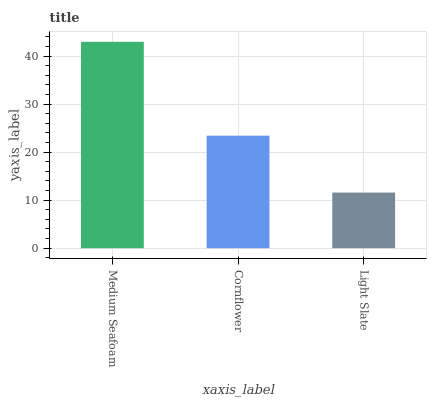Is Light Slate the minimum?
Answer yes or no. Yes. Is Medium Seafoam the maximum?
Answer yes or no. Yes. Is Cornflower the minimum?
Answer yes or no. No. Is Cornflower the maximum?
Answer yes or no. No. Is Medium Seafoam greater than Cornflower?
Answer yes or no. Yes. Is Cornflower less than Medium Seafoam?
Answer yes or no. Yes. Is Cornflower greater than Medium Seafoam?
Answer yes or no. No. Is Medium Seafoam less than Cornflower?
Answer yes or no. No. Is Cornflower the high median?
Answer yes or no. Yes. Is Cornflower the low median?
Answer yes or no. Yes. Is Light Slate the high median?
Answer yes or no. No. Is Medium Seafoam the low median?
Answer yes or no. No. 